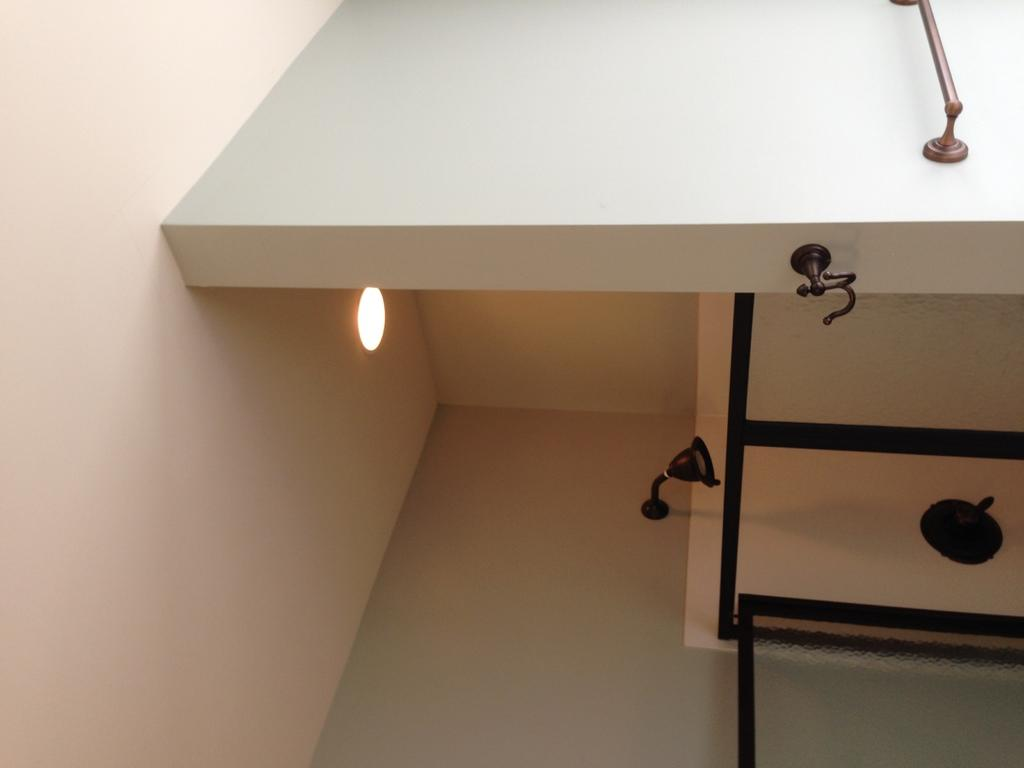What type of structure can be seen in the image? There are walls in the image. What can be found on the right side of the image? On the right side of the image, there are glass objects and an unspecified object. Can you describe the holder in the image? There is a holder in the image, but its specific purpose or contents are not mentioned. What is the rod used for in the image? The purpose of the rod in the image is not specified. What type of engine can be seen in the image? There is no engine present in the image. Is the rifle used for any specific purpose in the image? There is no rifle present in the image. 